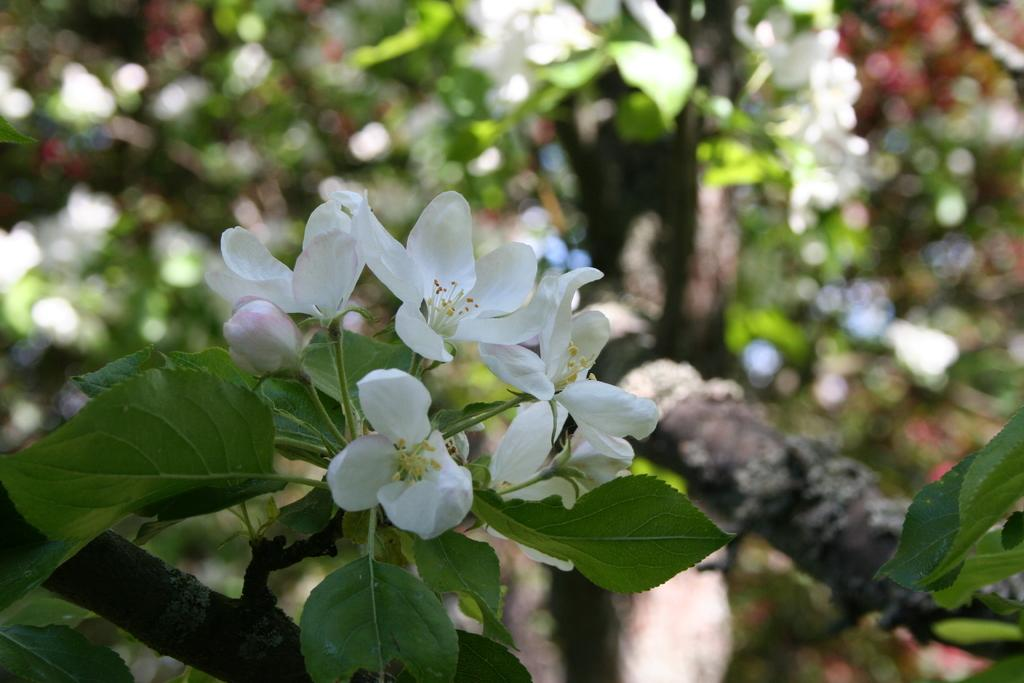What type of plant is featured in the image? There is a plant with white flowers in the image. Are there any other plants visible in the image? There are other plants visible in the background, but they are not clearly visible. How does the steam from the bag affect the growth of the plants in the image? There is no bag or steam present in the image, so this question cannot be answered. 